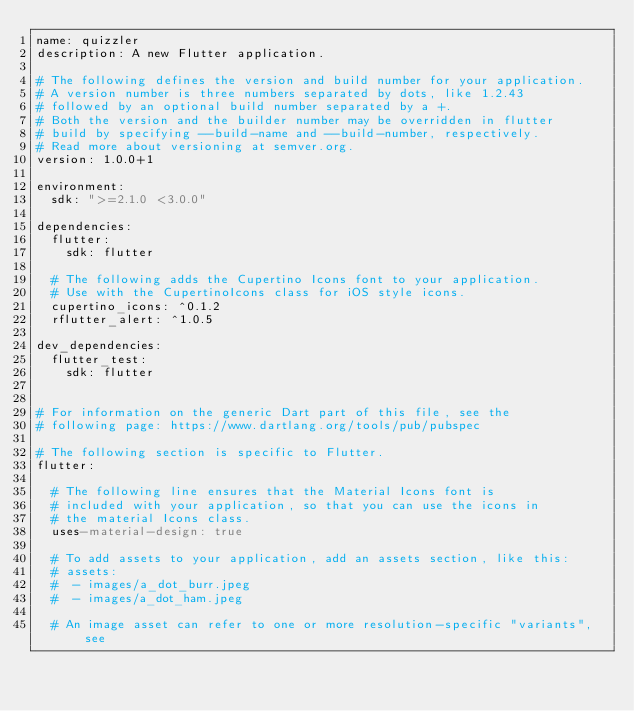Convert code to text. <code><loc_0><loc_0><loc_500><loc_500><_YAML_>name: quizzler
description: A new Flutter application.

# The following defines the version and build number for your application.
# A version number is three numbers separated by dots, like 1.2.43
# followed by an optional build number separated by a +.
# Both the version and the builder number may be overridden in flutter
# build by specifying --build-name and --build-number, respectively.
# Read more about versioning at semver.org.
version: 1.0.0+1

environment:
  sdk: ">=2.1.0 <3.0.0"

dependencies:
  flutter:
    sdk: flutter

  # The following adds the Cupertino Icons font to your application.
  # Use with the CupertinoIcons class for iOS style icons.
  cupertino_icons: ^0.1.2
  rflutter_alert: ^1.0.5

dev_dependencies:
  flutter_test:
    sdk: flutter


# For information on the generic Dart part of this file, see the
# following page: https://www.dartlang.org/tools/pub/pubspec

# The following section is specific to Flutter.
flutter:

  # The following line ensures that the Material Icons font is
  # included with your application, so that you can use the icons in
  # the material Icons class.
  uses-material-design: true

  # To add assets to your application, add an assets section, like this:
  # assets:
  #  - images/a_dot_burr.jpeg
  #  - images/a_dot_ham.jpeg

  # An image asset can refer to one or more resolution-specific "variants", see</code> 